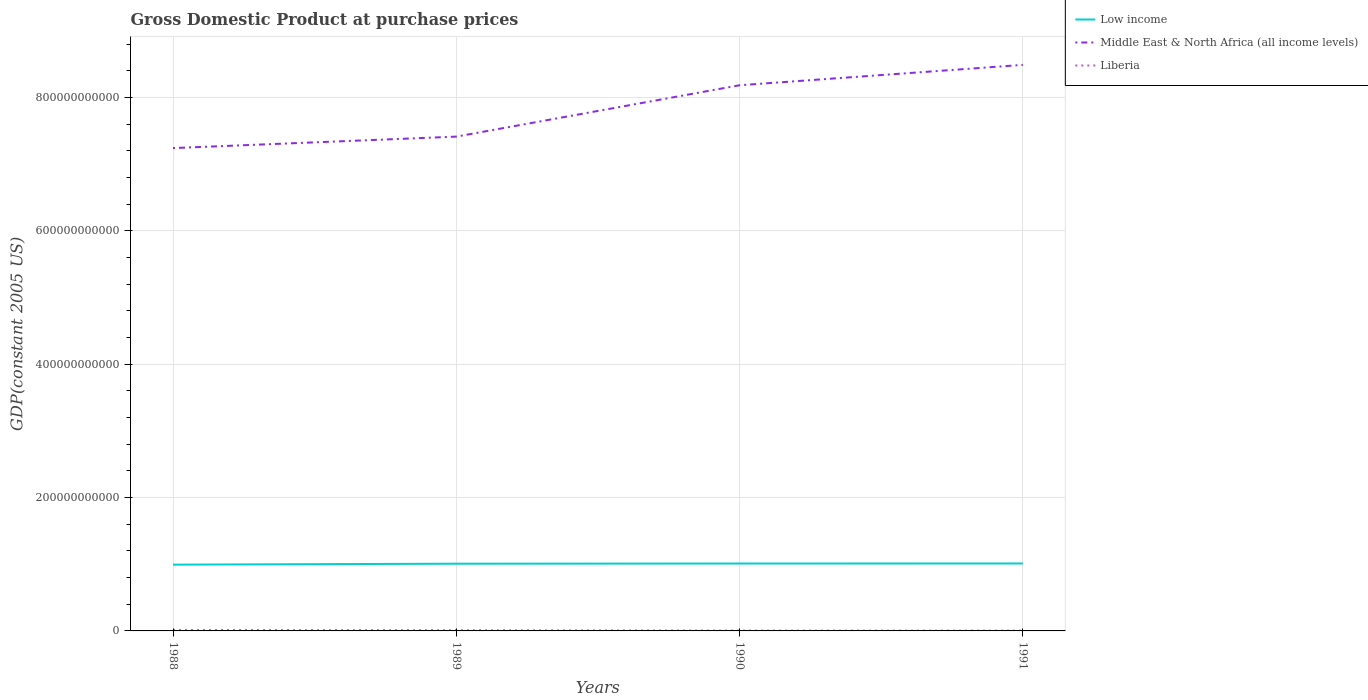How many different coloured lines are there?
Your answer should be very brief. 3. Across all years, what is the maximum GDP at purchase prices in Low income?
Give a very brief answer. 9.94e+1. In which year was the GDP at purchase prices in Middle East & North Africa (all income levels) maximum?
Make the answer very short. 1988. What is the total GDP at purchase prices in Middle East & North Africa (all income levels) in the graph?
Ensure brevity in your answer.  -7.70e+1. What is the difference between the highest and the second highest GDP at purchase prices in Low income?
Provide a succinct answer. 1.74e+09. What is the difference between two consecutive major ticks on the Y-axis?
Provide a succinct answer. 2.00e+11. Are the values on the major ticks of Y-axis written in scientific E-notation?
Provide a succinct answer. No. Does the graph contain any zero values?
Make the answer very short. No. Does the graph contain grids?
Offer a terse response. Yes. What is the title of the graph?
Your answer should be very brief. Gross Domestic Product at purchase prices. What is the label or title of the X-axis?
Keep it short and to the point. Years. What is the label or title of the Y-axis?
Your answer should be compact. GDP(constant 2005 US). What is the GDP(constant 2005 US) in Low income in 1988?
Provide a succinct answer. 9.94e+1. What is the GDP(constant 2005 US) of Middle East & North Africa (all income levels) in 1988?
Your answer should be very brief. 7.24e+11. What is the GDP(constant 2005 US) of Liberia in 1988?
Provide a short and direct response. 1.44e+09. What is the GDP(constant 2005 US) of Low income in 1989?
Offer a terse response. 1.01e+11. What is the GDP(constant 2005 US) of Middle East & North Africa (all income levels) in 1989?
Provide a succinct answer. 7.41e+11. What is the GDP(constant 2005 US) of Liberia in 1989?
Keep it short and to the point. 1.06e+09. What is the GDP(constant 2005 US) of Low income in 1990?
Provide a short and direct response. 1.01e+11. What is the GDP(constant 2005 US) of Middle East & North Africa (all income levels) in 1990?
Keep it short and to the point. 8.19e+11. What is the GDP(constant 2005 US) in Liberia in 1990?
Ensure brevity in your answer.  5.18e+08. What is the GDP(constant 2005 US) in Low income in 1991?
Offer a very short reply. 1.01e+11. What is the GDP(constant 2005 US) of Middle East & North Africa (all income levels) in 1991?
Offer a terse response. 8.49e+11. What is the GDP(constant 2005 US) in Liberia in 1991?
Give a very brief answer. 4.44e+08. Across all years, what is the maximum GDP(constant 2005 US) in Low income?
Provide a succinct answer. 1.01e+11. Across all years, what is the maximum GDP(constant 2005 US) of Middle East & North Africa (all income levels)?
Your answer should be very brief. 8.49e+11. Across all years, what is the maximum GDP(constant 2005 US) in Liberia?
Your answer should be very brief. 1.44e+09. Across all years, what is the minimum GDP(constant 2005 US) of Low income?
Make the answer very short. 9.94e+1. Across all years, what is the minimum GDP(constant 2005 US) in Middle East & North Africa (all income levels)?
Your answer should be compact. 7.24e+11. Across all years, what is the minimum GDP(constant 2005 US) in Liberia?
Make the answer very short. 4.44e+08. What is the total GDP(constant 2005 US) of Low income in the graph?
Give a very brief answer. 4.03e+11. What is the total GDP(constant 2005 US) of Middle East & North Africa (all income levels) in the graph?
Make the answer very short. 3.13e+12. What is the total GDP(constant 2005 US) in Liberia in the graph?
Your response must be concise. 3.46e+09. What is the difference between the GDP(constant 2005 US) of Low income in 1988 and that in 1989?
Give a very brief answer. -1.41e+09. What is the difference between the GDP(constant 2005 US) in Middle East & North Africa (all income levels) in 1988 and that in 1989?
Provide a short and direct response. -1.72e+1. What is the difference between the GDP(constant 2005 US) of Liberia in 1988 and that in 1989?
Your answer should be very brief. 3.84e+08. What is the difference between the GDP(constant 2005 US) of Low income in 1988 and that in 1990?
Your response must be concise. -1.68e+09. What is the difference between the GDP(constant 2005 US) in Middle East & North Africa (all income levels) in 1988 and that in 1990?
Ensure brevity in your answer.  -9.43e+1. What is the difference between the GDP(constant 2005 US) of Liberia in 1988 and that in 1990?
Your answer should be compact. 9.24e+08. What is the difference between the GDP(constant 2005 US) of Low income in 1988 and that in 1991?
Keep it short and to the point. -1.74e+09. What is the difference between the GDP(constant 2005 US) in Middle East & North Africa (all income levels) in 1988 and that in 1991?
Provide a succinct answer. -1.25e+11. What is the difference between the GDP(constant 2005 US) of Liberia in 1988 and that in 1991?
Offer a terse response. 9.98e+08. What is the difference between the GDP(constant 2005 US) of Low income in 1989 and that in 1990?
Your answer should be compact. -2.73e+08. What is the difference between the GDP(constant 2005 US) in Middle East & North Africa (all income levels) in 1989 and that in 1990?
Give a very brief answer. -7.70e+1. What is the difference between the GDP(constant 2005 US) of Liberia in 1989 and that in 1990?
Give a very brief answer. 5.40e+08. What is the difference between the GDP(constant 2005 US) in Low income in 1989 and that in 1991?
Provide a short and direct response. -3.28e+08. What is the difference between the GDP(constant 2005 US) of Middle East & North Africa (all income levels) in 1989 and that in 1991?
Give a very brief answer. -1.08e+11. What is the difference between the GDP(constant 2005 US) in Liberia in 1989 and that in 1991?
Offer a terse response. 6.13e+08. What is the difference between the GDP(constant 2005 US) of Low income in 1990 and that in 1991?
Offer a very short reply. -5.51e+07. What is the difference between the GDP(constant 2005 US) in Middle East & North Africa (all income levels) in 1990 and that in 1991?
Ensure brevity in your answer.  -3.06e+1. What is the difference between the GDP(constant 2005 US) of Liberia in 1990 and that in 1991?
Provide a succinct answer. 7.36e+07. What is the difference between the GDP(constant 2005 US) of Low income in 1988 and the GDP(constant 2005 US) of Middle East & North Africa (all income levels) in 1989?
Offer a terse response. -6.42e+11. What is the difference between the GDP(constant 2005 US) in Low income in 1988 and the GDP(constant 2005 US) in Liberia in 1989?
Offer a terse response. 9.84e+1. What is the difference between the GDP(constant 2005 US) of Middle East & North Africa (all income levels) in 1988 and the GDP(constant 2005 US) of Liberia in 1989?
Make the answer very short. 7.23e+11. What is the difference between the GDP(constant 2005 US) in Low income in 1988 and the GDP(constant 2005 US) in Middle East & North Africa (all income levels) in 1990?
Make the answer very short. -7.19e+11. What is the difference between the GDP(constant 2005 US) of Low income in 1988 and the GDP(constant 2005 US) of Liberia in 1990?
Your response must be concise. 9.89e+1. What is the difference between the GDP(constant 2005 US) of Middle East & North Africa (all income levels) in 1988 and the GDP(constant 2005 US) of Liberia in 1990?
Offer a very short reply. 7.24e+11. What is the difference between the GDP(constant 2005 US) of Low income in 1988 and the GDP(constant 2005 US) of Middle East & North Africa (all income levels) in 1991?
Offer a very short reply. -7.50e+11. What is the difference between the GDP(constant 2005 US) of Low income in 1988 and the GDP(constant 2005 US) of Liberia in 1991?
Give a very brief answer. 9.90e+1. What is the difference between the GDP(constant 2005 US) of Middle East & North Africa (all income levels) in 1988 and the GDP(constant 2005 US) of Liberia in 1991?
Offer a very short reply. 7.24e+11. What is the difference between the GDP(constant 2005 US) of Low income in 1989 and the GDP(constant 2005 US) of Middle East & North Africa (all income levels) in 1990?
Make the answer very short. -7.18e+11. What is the difference between the GDP(constant 2005 US) of Low income in 1989 and the GDP(constant 2005 US) of Liberia in 1990?
Provide a short and direct response. 1.00e+11. What is the difference between the GDP(constant 2005 US) of Middle East & North Africa (all income levels) in 1989 and the GDP(constant 2005 US) of Liberia in 1990?
Ensure brevity in your answer.  7.41e+11. What is the difference between the GDP(constant 2005 US) in Low income in 1989 and the GDP(constant 2005 US) in Middle East & North Africa (all income levels) in 1991?
Provide a short and direct response. -7.48e+11. What is the difference between the GDP(constant 2005 US) of Low income in 1989 and the GDP(constant 2005 US) of Liberia in 1991?
Ensure brevity in your answer.  1.00e+11. What is the difference between the GDP(constant 2005 US) in Middle East & North Africa (all income levels) in 1989 and the GDP(constant 2005 US) in Liberia in 1991?
Your answer should be very brief. 7.41e+11. What is the difference between the GDP(constant 2005 US) in Low income in 1990 and the GDP(constant 2005 US) in Middle East & North Africa (all income levels) in 1991?
Keep it short and to the point. -7.48e+11. What is the difference between the GDP(constant 2005 US) in Low income in 1990 and the GDP(constant 2005 US) in Liberia in 1991?
Your answer should be compact. 1.01e+11. What is the difference between the GDP(constant 2005 US) in Middle East & North Africa (all income levels) in 1990 and the GDP(constant 2005 US) in Liberia in 1991?
Make the answer very short. 8.18e+11. What is the average GDP(constant 2005 US) of Low income per year?
Provide a succinct answer. 1.01e+11. What is the average GDP(constant 2005 US) in Middle East & North Africa (all income levels) per year?
Your response must be concise. 7.83e+11. What is the average GDP(constant 2005 US) in Liberia per year?
Your answer should be very brief. 8.65e+08. In the year 1988, what is the difference between the GDP(constant 2005 US) of Low income and GDP(constant 2005 US) of Middle East & North Africa (all income levels)?
Give a very brief answer. -6.25e+11. In the year 1988, what is the difference between the GDP(constant 2005 US) in Low income and GDP(constant 2005 US) in Liberia?
Provide a short and direct response. 9.80e+1. In the year 1988, what is the difference between the GDP(constant 2005 US) of Middle East & North Africa (all income levels) and GDP(constant 2005 US) of Liberia?
Offer a terse response. 7.23e+11. In the year 1989, what is the difference between the GDP(constant 2005 US) of Low income and GDP(constant 2005 US) of Middle East & North Africa (all income levels)?
Your answer should be compact. -6.41e+11. In the year 1989, what is the difference between the GDP(constant 2005 US) in Low income and GDP(constant 2005 US) in Liberia?
Provide a succinct answer. 9.98e+1. In the year 1989, what is the difference between the GDP(constant 2005 US) of Middle East & North Africa (all income levels) and GDP(constant 2005 US) of Liberia?
Your answer should be very brief. 7.40e+11. In the year 1990, what is the difference between the GDP(constant 2005 US) of Low income and GDP(constant 2005 US) of Middle East & North Africa (all income levels)?
Your answer should be very brief. -7.17e+11. In the year 1990, what is the difference between the GDP(constant 2005 US) of Low income and GDP(constant 2005 US) of Liberia?
Your response must be concise. 1.01e+11. In the year 1990, what is the difference between the GDP(constant 2005 US) of Middle East & North Africa (all income levels) and GDP(constant 2005 US) of Liberia?
Your answer should be very brief. 8.18e+11. In the year 1991, what is the difference between the GDP(constant 2005 US) of Low income and GDP(constant 2005 US) of Middle East & North Africa (all income levels)?
Provide a succinct answer. -7.48e+11. In the year 1991, what is the difference between the GDP(constant 2005 US) in Low income and GDP(constant 2005 US) in Liberia?
Keep it short and to the point. 1.01e+11. In the year 1991, what is the difference between the GDP(constant 2005 US) in Middle East & North Africa (all income levels) and GDP(constant 2005 US) in Liberia?
Provide a succinct answer. 8.49e+11. What is the ratio of the GDP(constant 2005 US) in Low income in 1988 to that in 1989?
Your answer should be very brief. 0.99. What is the ratio of the GDP(constant 2005 US) of Middle East & North Africa (all income levels) in 1988 to that in 1989?
Your answer should be very brief. 0.98. What is the ratio of the GDP(constant 2005 US) of Liberia in 1988 to that in 1989?
Your answer should be compact. 1.36. What is the ratio of the GDP(constant 2005 US) of Low income in 1988 to that in 1990?
Make the answer very short. 0.98. What is the ratio of the GDP(constant 2005 US) of Middle East & North Africa (all income levels) in 1988 to that in 1990?
Give a very brief answer. 0.88. What is the ratio of the GDP(constant 2005 US) of Liberia in 1988 to that in 1990?
Offer a terse response. 2.78. What is the ratio of the GDP(constant 2005 US) of Low income in 1988 to that in 1991?
Your response must be concise. 0.98. What is the ratio of the GDP(constant 2005 US) of Middle East & North Africa (all income levels) in 1988 to that in 1991?
Give a very brief answer. 0.85. What is the ratio of the GDP(constant 2005 US) of Liberia in 1988 to that in 1991?
Your response must be concise. 3.25. What is the ratio of the GDP(constant 2005 US) in Middle East & North Africa (all income levels) in 1989 to that in 1990?
Give a very brief answer. 0.91. What is the ratio of the GDP(constant 2005 US) of Liberia in 1989 to that in 1990?
Offer a terse response. 2.04. What is the ratio of the GDP(constant 2005 US) in Low income in 1989 to that in 1991?
Offer a terse response. 1. What is the ratio of the GDP(constant 2005 US) in Middle East & North Africa (all income levels) in 1989 to that in 1991?
Your answer should be compact. 0.87. What is the ratio of the GDP(constant 2005 US) in Liberia in 1989 to that in 1991?
Your answer should be very brief. 2.38. What is the ratio of the GDP(constant 2005 US) of Low income in 1990 to that in 1991?
Offer a terse response. 1. What is the ratio of the GDP(constant 2005 US) of Middle East & North Africa (all income levels) in 1990 to that in 1991?
Ensure brevity in your answer.  0.96. What is the ratio of the GDP(constant 2005 US) of Liberia in 1990 to that in 1991?
Provide a short and direct response. 1.17. What is the difference between the highest and the second highest GDP(constant 2005 US) of Low income?
Keep it short and to the point. 5.51e+07. What is the difference between the highest and the second highest GDP(constant 2005 US) in Middle East & North Africa (all income levels)?
Offer a very short reply. 3.06e+1. What is the difference between the highest and the second highest GDP(constant 2005 US) in Liberia?
Provide a short and direct response. 3.84e+08. What is the difference between the highest and the lowest GDP(constant 2005 US) of Low income?
Make the answer very short. 1.74e+09. What is the difference between the highest and the lowest GDP(constant 2005 US) in Middle East & North Africa (all income levels)?
Ensure brevity in your answer.  1.25e+11. What is the difference between the highest and the lowest GDP(constant 2005 US) in Liberia?
Your answer should be compact. 9.98e+08. 